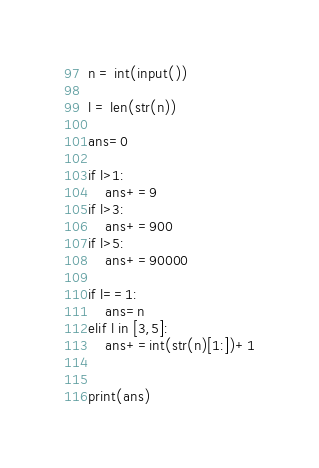<code> <loc_0><loc_0><loc_500><loc_500><_Python_>n = int(input())

l = len(str(n))

ans=0

if l>1:
    ans+=9
if l>3:
    ans+=900
if l>5:
    ans+=90000

if l==1:
    ans=n
elif l in [3,5]:
    ans+=int(str(n)[1:])+1


print(ans)</code> 